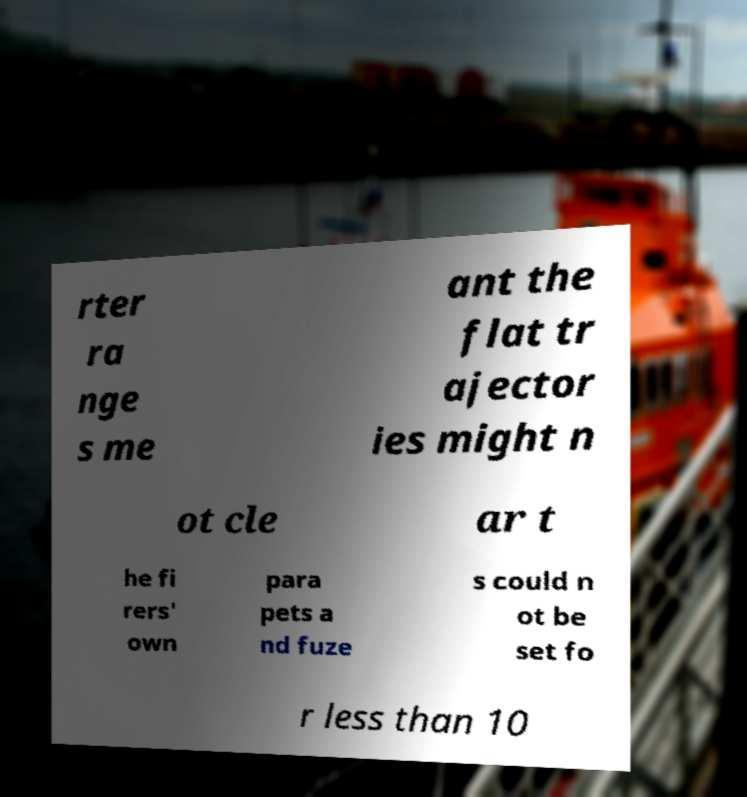Please identify and transcribe the text found in this image. rter ra nge s me ant the flat tr ajector ies might n ot cle ar t he fi rers' own para pets a nd fuze s could n ot be set fo r less than 10 